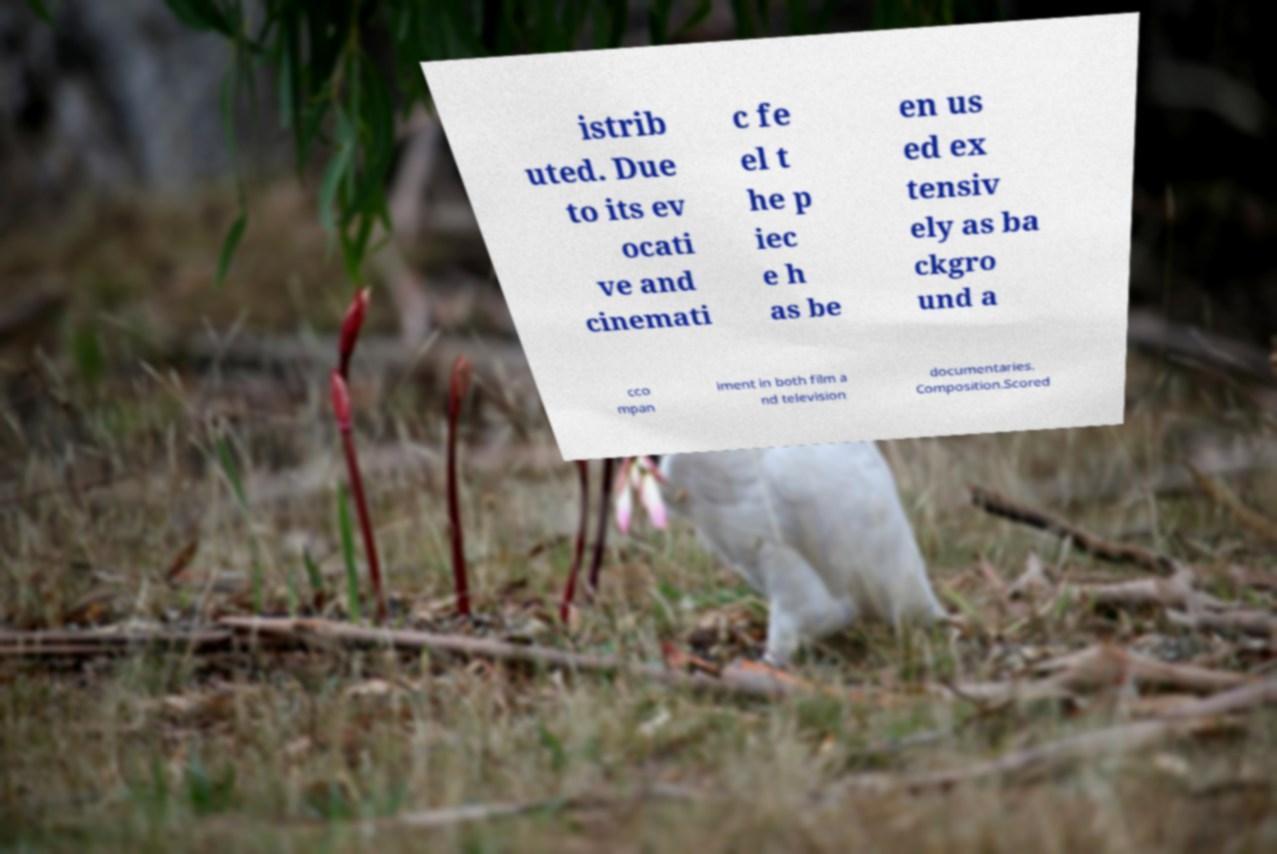What messages or text are displayed in this image? I need them in a readable, typed format. istrib uted. Due to its ev ocati ve and cinemati c fe el t he p iec e h as be en us ed ex tensiv ely as ba ckgro und a cco mpan iment in both film a nd television documentaries. Composition.Scored 